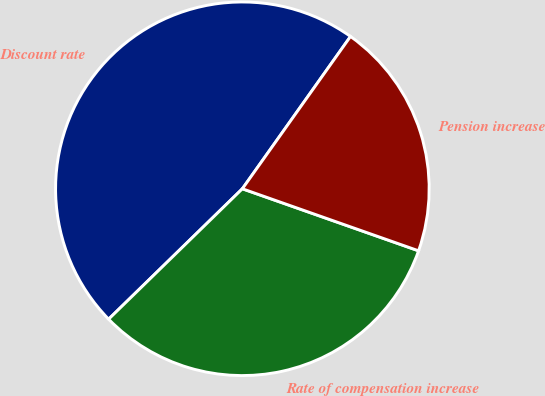Convert chart to OTSL. <chart><loc_0><loc_0><loc_500><loc_500><pie_chart><fcel>Discount rate<fcel>Rate of compensation increase<fcel>Pension increase<nl><fcel>47.12%<fcel>32.31%<fcel>20.56%<nl></chart> 